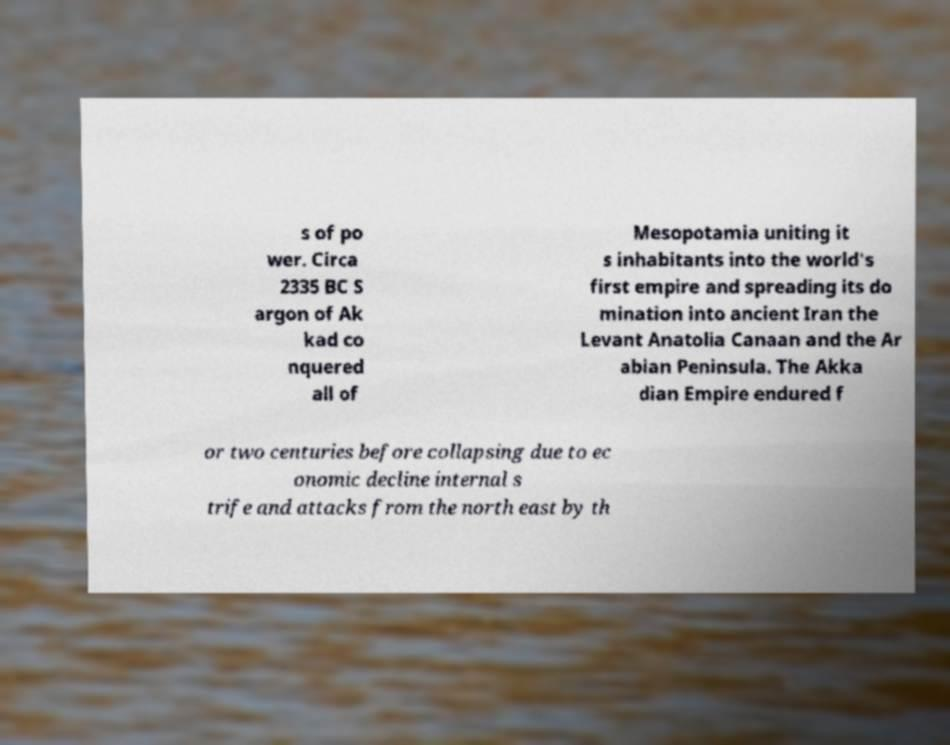What messages or text are displayed in this image? I need them in a readable, typed format. s of po wer. Circa 2335 BC S argon of Ak kad co nquered all of Mesopotamia uniting it s inhabitants into the world's first empire and spreading its do mination into ancient Iran the Levant Anatolia Canaan and the Ar abian Peninsula. The Akka dian Empire endured f or two centuries before collapsing due to ec onomic decline internal s trife and attacks from the north east by th 